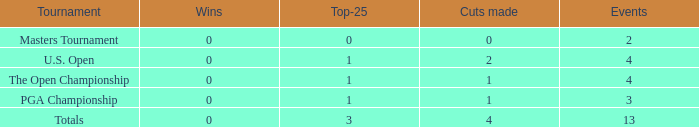How many cuts made in the tournament he played 13 times? None. 